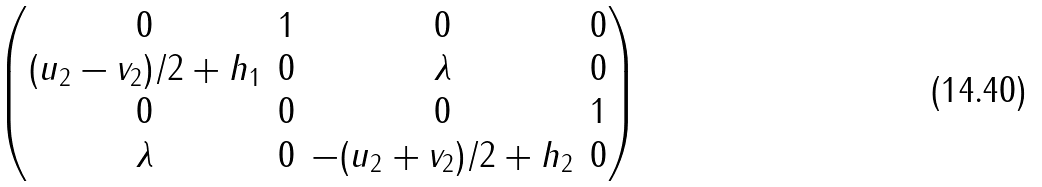<formula> <loc_0><loc_0><loc_500><loc_500>\begin{pmatrix} 0 & 1 & 0 & 0 \\ ( u _ { 2 } - v _ { 2 } ) / 2 + h _ { 1 } & 0 & \lambda & 0 \\ 0 & 0 & 0 & 1 \\ \lambda & 0 & - ( u _ { 2 } + v _ { 2 } ) / 2 + h _ { 2 } & 0 \end{pmatrix}</formula> 